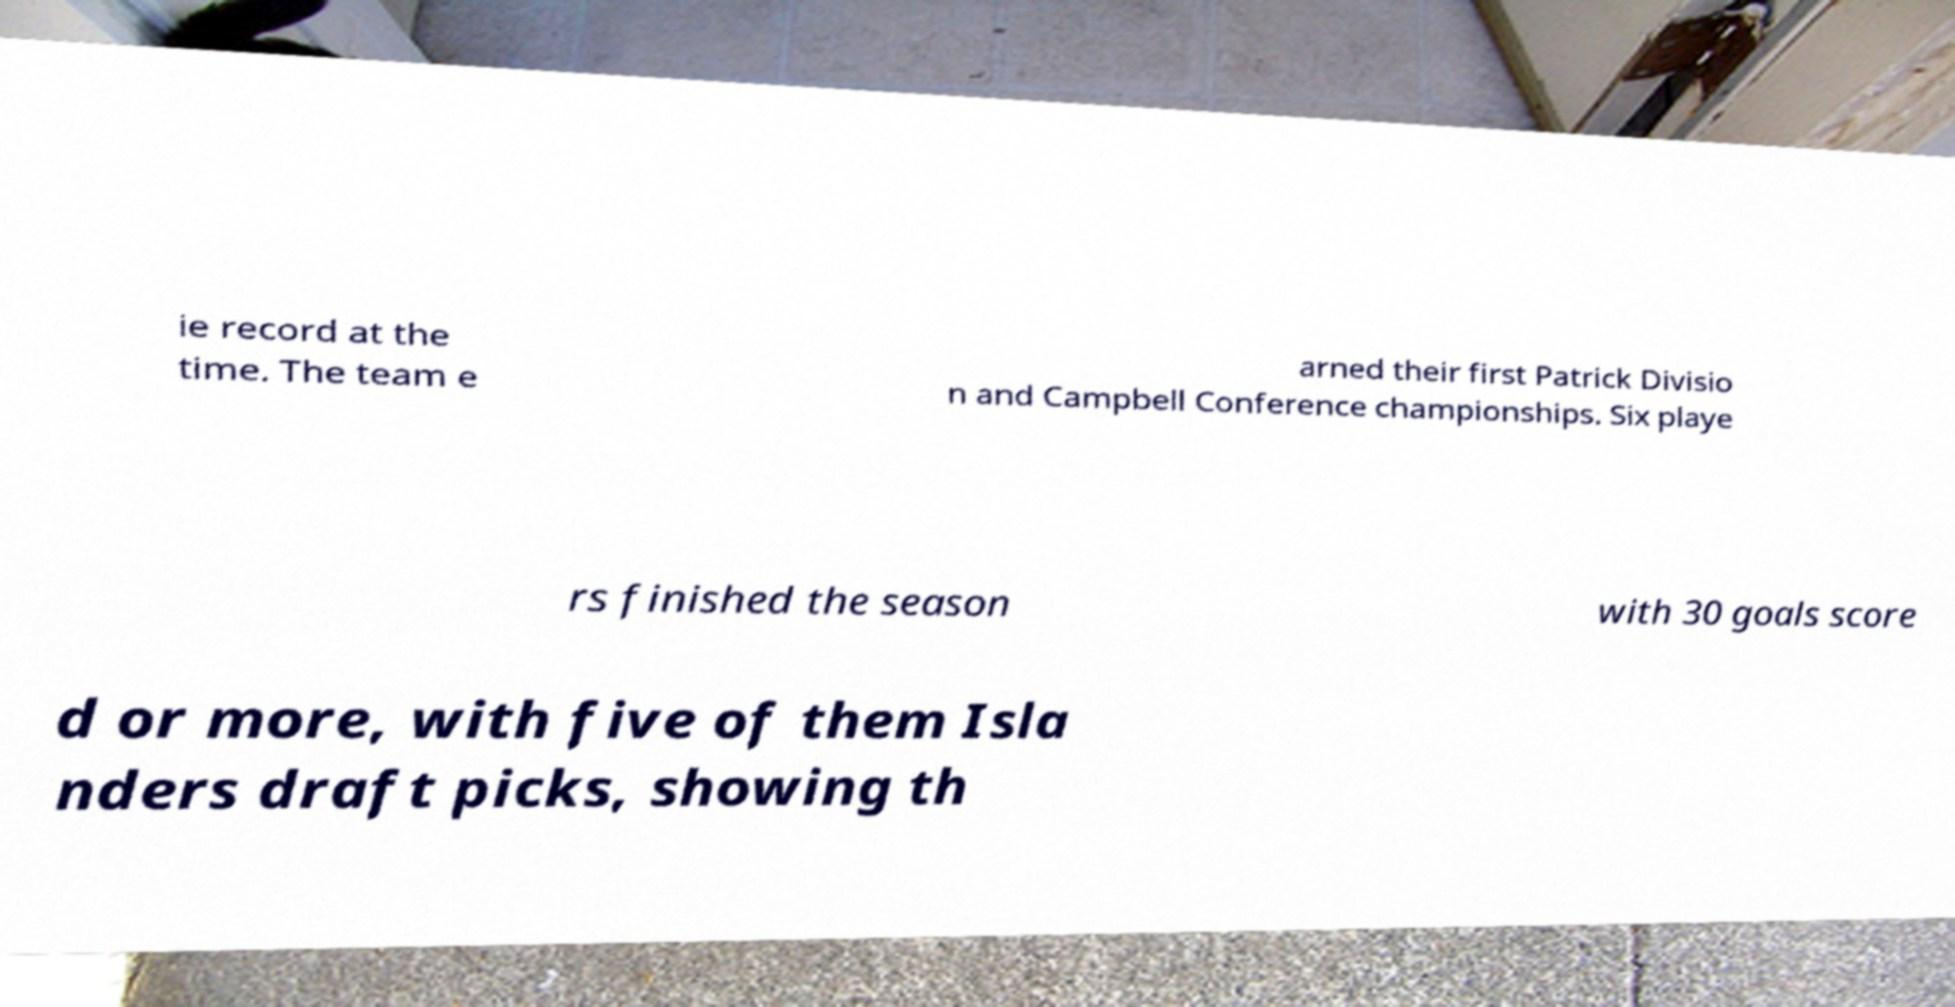Can you accurately transcribe the text from the provided image for me? ie record at the time. The team e arned their first Patrick Divisio n and Campbell Conference championships. Six playe rs finished the season with 30 goals score d or more, with five of them Isla nders draft picks, showing th 